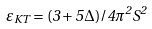<formula> <loc_0><loc_0><loc_500><loc_500>\varepsilon _ { K T } = ( 3 + 5 \Delta ) / 4 \pi ^ { 2 } S ^ { 2 }</formula> 